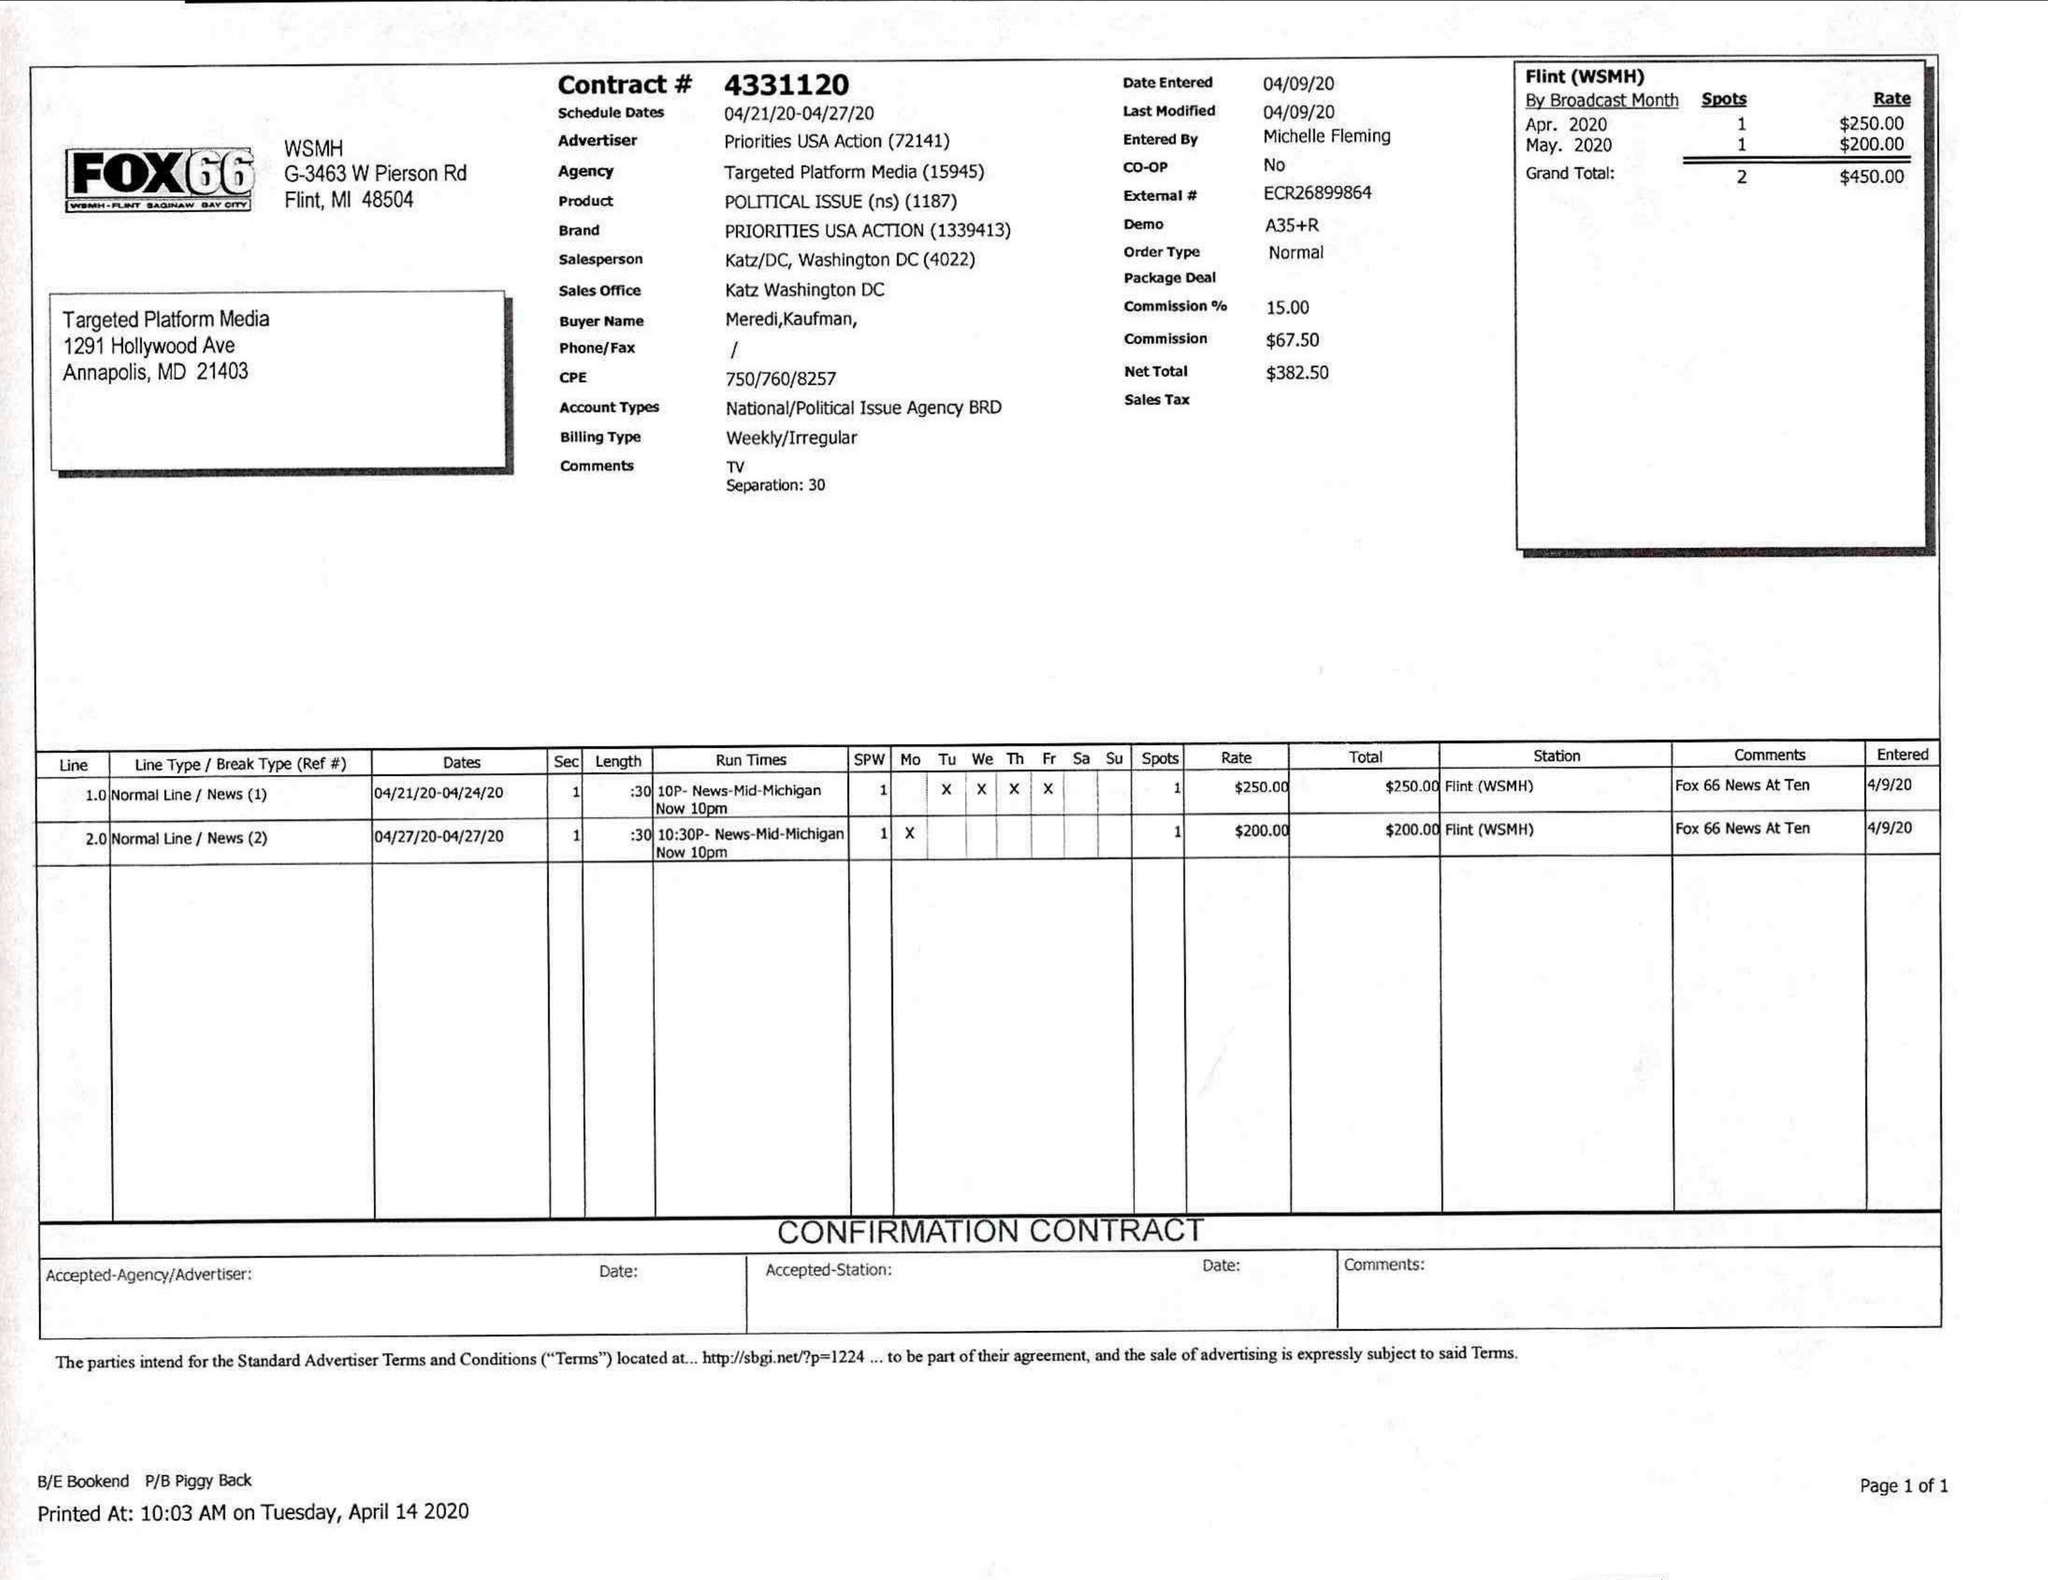What is the value for the gross_amount?
Answer the question using a single word or phrase. 450.00 